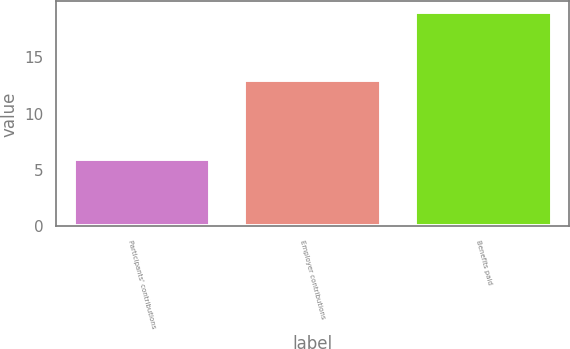<chart> <loc_0><loc_0><loc_500><loc_500><bar_chart><fcel>Participants' contributions<fcel>Employer contributions<fcel>Benefits paid<nl><fcel>6<fcel>13<fcel>19<nl></chart> 